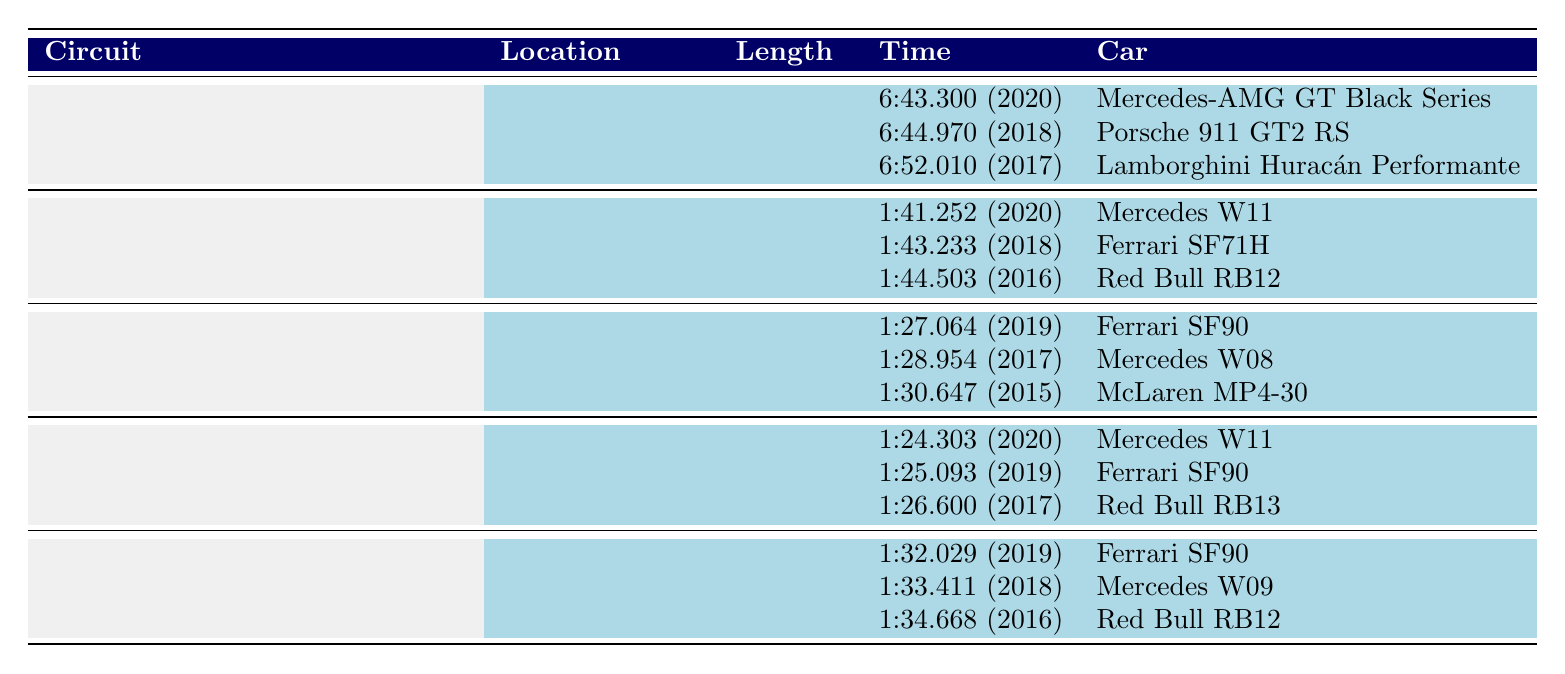What is the fastest lap time recorded at the Nürburgring Nordschleife? The fastest lap time recorded at the Nürburgring Nordschleife is 6:43.300 in 2020 by the Mercedes-AMG GT Black Series.
Answer: 6:43.300 Which car made the fastest lap at Circuit de Spa-Francorchamps in 2020? The fastest lap at Circuit de Spa-Francorchamps in 2020 was made by Mercedes with the W11 model.
Answer: Mercedes W11 How many circuits have lap times recorded by Ferrari? The circuits with lap times recorded by Ferrari are Circuit de Spa-Francorchamps, Suzuka Circuit, Silverstone Circuit, and Circuit of the Americas, making a total of 4 circuits.
Answer: 4 Which car has the second fastest lap at Suzuka Circuit and what is the time? The second fastest lap at Suzuka Circuit is by Mercedes W08 with a time of 1:28.954 in 2017.
Answer: Mercedes W08 - 1:28.954 Is there a Ferrari model that holds the fastest lap time at multiple circuits? Yes, the Ferrari SF90 holds the fastest lap time at both Suzuka Circuit and Circuit of the Americas.
Answer: Yes What is the average lap time of the Ferrari SF90 across all circuits it has recorded? The lap times for Ferrari SF90 are 1:27.064 (Suzuka) and 1:32.029 (Circuit of the Americas). Converting these to seconds: 87.064 + 92.029 = 179.093 seconds. Divided by 2 gives an average of 89.5465 seconds, which is approximately 1:29.547.
Answer: 1:29.547 Who holds the fastest lap overall among all circuits listed in the data? The fastest lap overall across all circuits listed is by Mercedes-AMG with the GT Black Series at 6:43.300 at the Nürburgring Nordschleife.
Answer: Mercedes-AMG GT Black Series What was the fastest lap time by Lamborghini, and at which circuit was it recorded? Lamborghini's fastest lap time is 6:52.010 recorded at the Nürburgring Nordschleife in 2017.
Answer: 6:52.010 at Nürburgring Nordschleife Which car make has achieved the most fastest lap records across all circuits in the data? Mercedes has achieved the most fastest lap records across the circuits with a total of 5 fastest lap times listed.
Answer: Mercedes What is the least fast lap time recorded for the car models listed? The least fast lap time recorded is for the Lamborghini Huracán Performante at 6:52.010 at the Nürburgring Nordschleife.
Answer: 6:52.010 